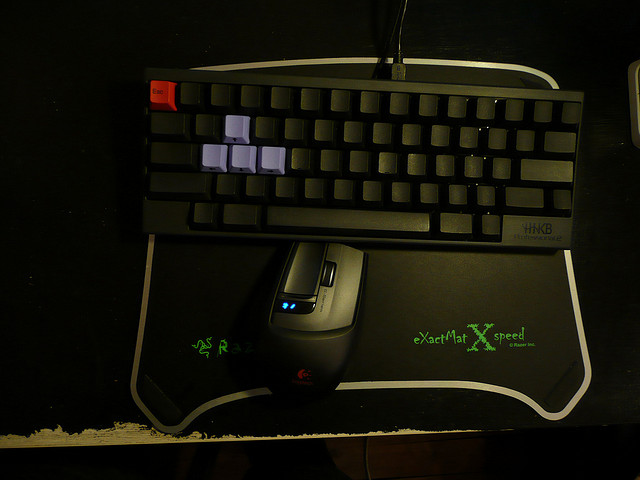<image>What does the apple represent? It is unknown what the apple represents. It could be a logo, brand, or symbol of temptation. What does the apple represent? It is unknown what the apple represents. It can be a logo, brand or fruit. 